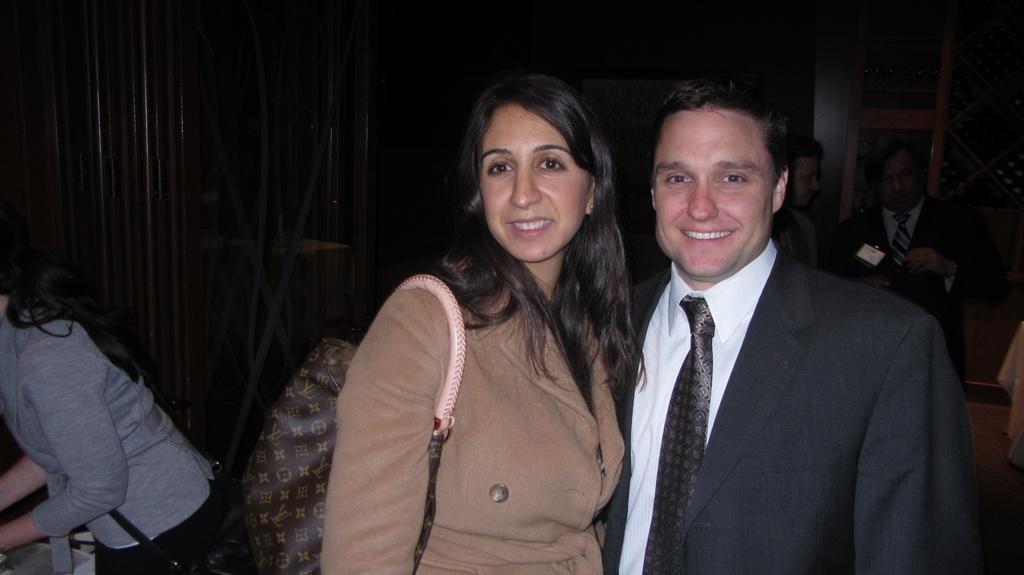Can you describe this image briefly? In the center of the image we can see two persons are standing and they are smiling. And the left side person is wearing a bag. On the left side of the image, we can see one person is standing. In front of her, we can see some objects. In the background there is a wall, pole type structures, one ladder, few people are standing and a few other objects. 